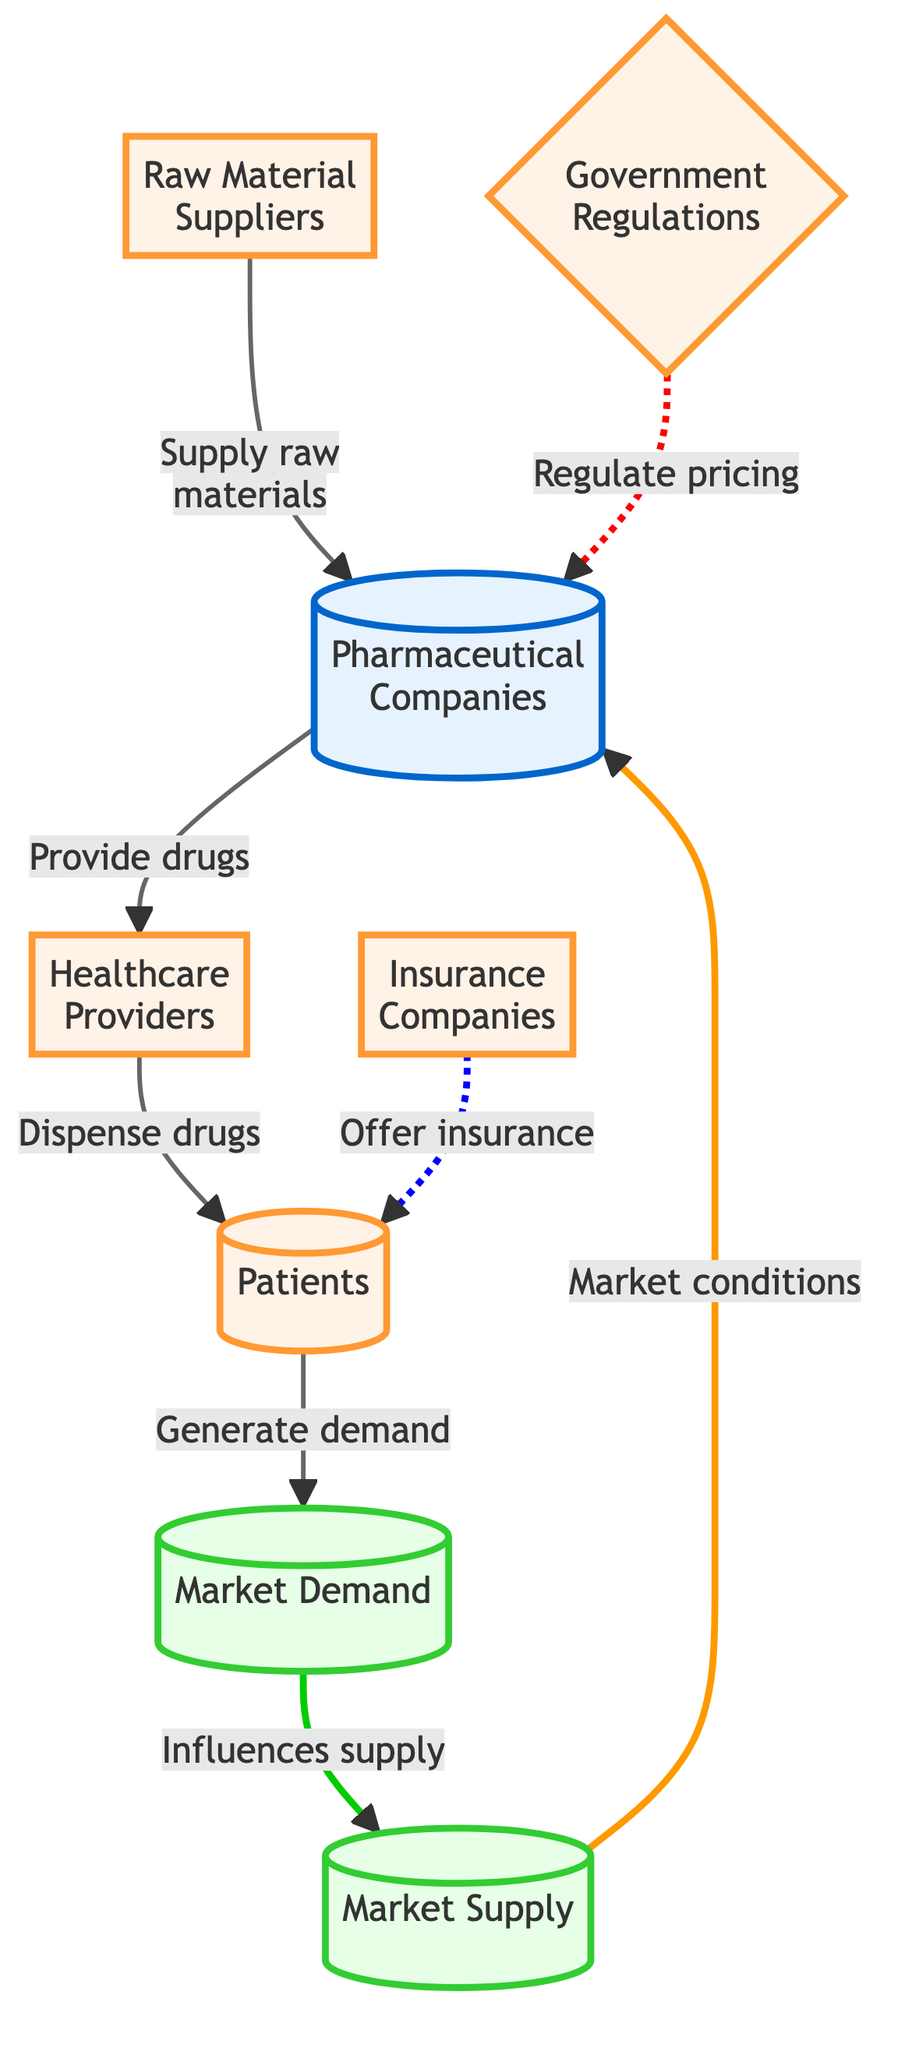What entities supply raw materials to pharmaceutical companies? In the diagram, the entity that supplies raw materials to pharmaceutical companies is explicitly labeled as "Raw Material Suppliers." Therefore, the answer is derived directly from the connections shown in the visual representation.
Answer: Raw Material Suppliers How many entities interact with patients? By reviewing the diagram, there are three entities that directly interact with patients: "Healthcare Providers," "Insurance Companies," and "Patients" itself. Therefore, the total count of entities that engage with patients is identified from the flow connections.
Answer: 3 What role do government regulations play in the pharmaceutical industry? The diagram illustrates that government regulations have a regulatory influence on pricing for pharmaceutical companies, represented by the dashed line connecting "Government Regulations" to "Pharmaceutical Companies." The explanation shows this specific connection and its influence.
Answer: Regulate pricing What influences the market supply in this diagram? The diagram indicates that "Market Demand" influences the "Market Supply." To reach this conclusion, one needs to trace the directed arrows that connect these two components and identify the influence relation they have on each other.
Answer: Market Demand How many total nodes are present in the diagram? Upon counting the visible nodes in the diagram, we find there are eight distinct nodes representing different entities and market forces. This count is derived from the overall structure of the diagram.
Answer: 8 What is the connection between patients and market demand? The diagram shows that patients generate demand as they interact with the healthcare providers. The relationship is visually represented by the arrow direction from "Patients" to "Market Demand," illustrating the flow of influence.
Answer: Generate demand What is the representation for market conditions in relation to pharmaceutical companies? The diagram states that "Market Supply" describes the conditions impacting "Pharmaceutical Companies." This is explained by the directed arrow connecting "Market Supply" to "Pharmaceutical Companies," indicating how supply conditions affect the companies.
Answer: Market conditions What is the role of healthcare providers in the drug supply chain? The healthcare providers serve the role of dispensing drugs to patients, as shown by the direct connection between "Healthcare Providers" and "Patients." The explanation comes from following the directional flow depicted in the diagram.
Answer: Dispense drugs 